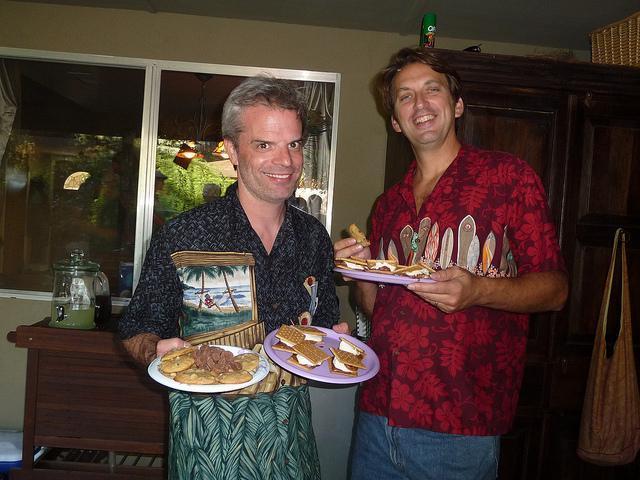How many people are there?
Give a very brief answer. 3. How many bottles are in the photo?
Give a very brief answer. 1. 